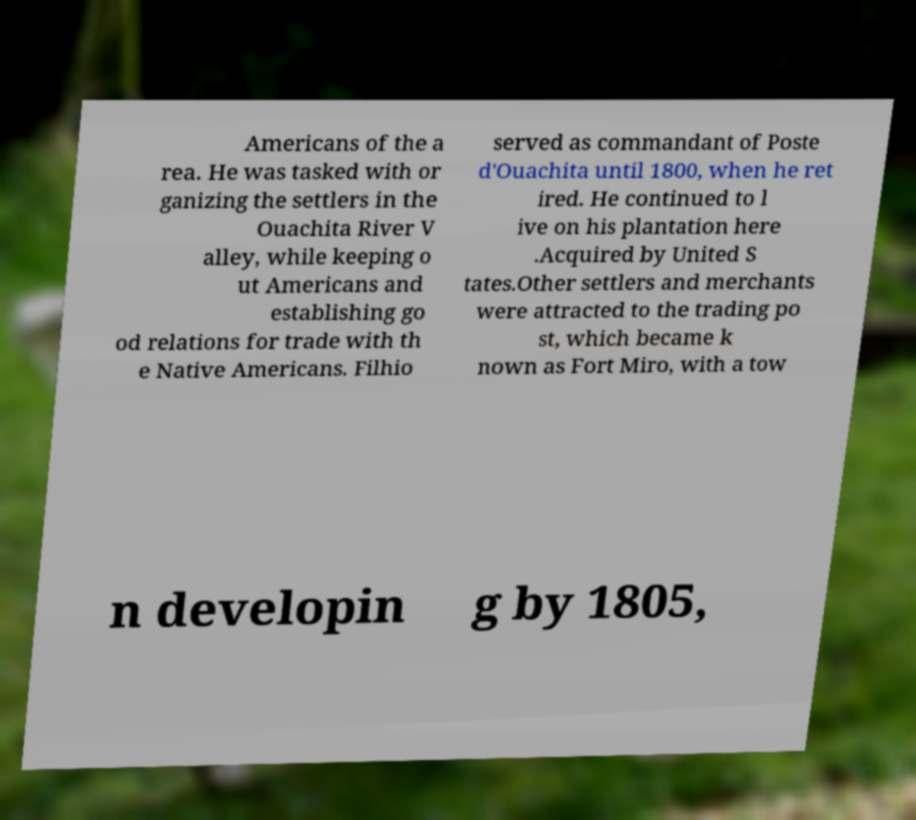For documentation purposes, I need the text within this image transcribed. Could you provide that? Americans of the a rea. He was tasked with or ganizing the settlers in the Ouachita River V alley, while keeping o ut Americans and establishing go od relations for trade with th e Native Americans. Filhio served as commandant of Poste d'Ouachita until 1800, when he ret ired. He continued to l ive on his plantation here .Acquired by United S tates.Other settlers and merchants were attracted to the trading po st, which became k nown as Fort Miro, with a tow n developin g by 1805, 